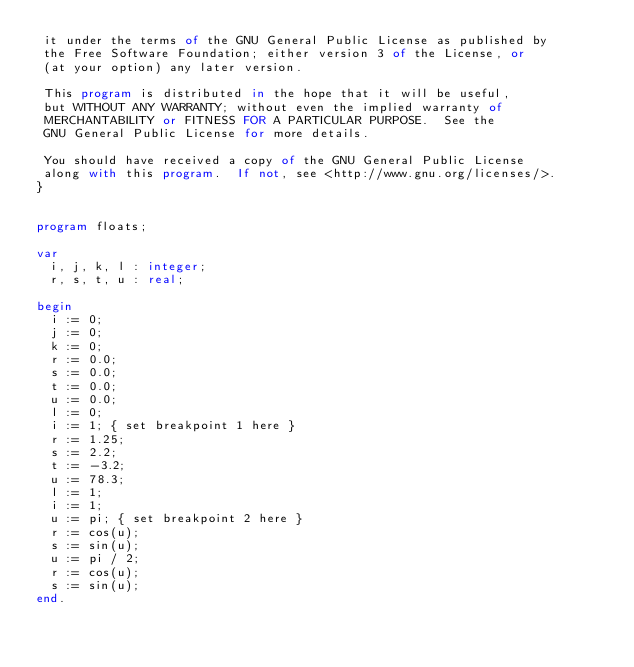Convert code to text. <code><loc_0><loc_0><loc_500><loc_500><_Pascal_> it under the terms of the GNU General Public License as published by
 the Free Software Foundation; either version 3 of the License, or
 (at your option) any later version.

 This program is distributed in the hope that it will be useful,
 but WITHOUT ANY WARRANTY; without even the implied warranty of
 MERCHANTABILITY or FITNESS FOR A PARTICULAR PURPOSE.  See the
 GNU General Public License for more details.

 You should have received a copy of the GNU General Public License
 along with this program.  If not, see <http://www.gnu.org/licenses/>.
}


program floats;

var
  i, j, k, l : integer;
  r, s, t, u : real;

begin
  i := 0;
  j := 0;
  k := 0;
  r := 0.0;
  s := 0.0;
  t := 0.0;
  u := 0.0;
  l := 0;
  i := 1; { set breakpoint 1 here }
  r := 1.25;
  s := 2.2;
  t := -3.2;
  u := 78.3;
  l := 1;
  i := 1;
  u := pi; { set breakpoint 2 here }
  r := cos(u);
  s := sin(u);
  u := pi / 2;
  r := cos(u);
  s := sin(u);
end.
</code> 